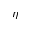<formula> <loc_0><loc_0><loc_500><loc_500>\eta</formula> 